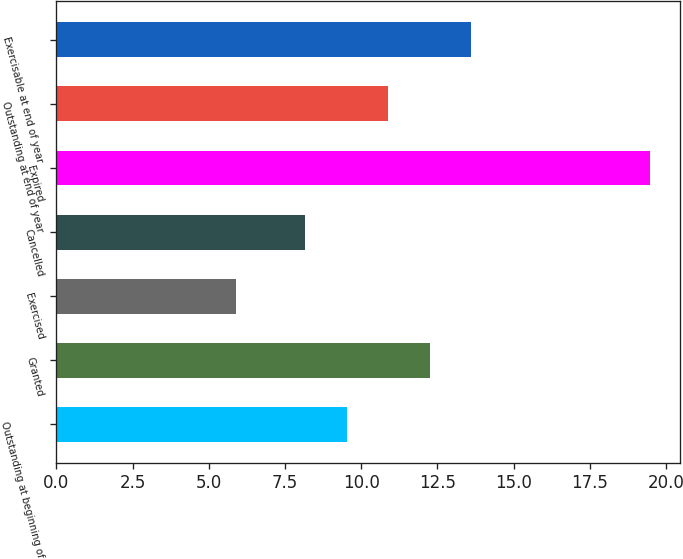Convert chart. <chart><loc_0><loc_0><loc_500><loc_500><bar_chart><fcel>Outstanding at beginning of<fcel>Granted<fcel>Exercised<fcel>Cancelled<fcel>Expired<fcel>Outstanding at end of year<fcel>Exercisable at end of year<nl><fcel>9.52<fcel>12.24<fcel>5.9<fcel>8.16<fcel>19.48<fcel>10.88<fcel>13.6<nl></chart> 